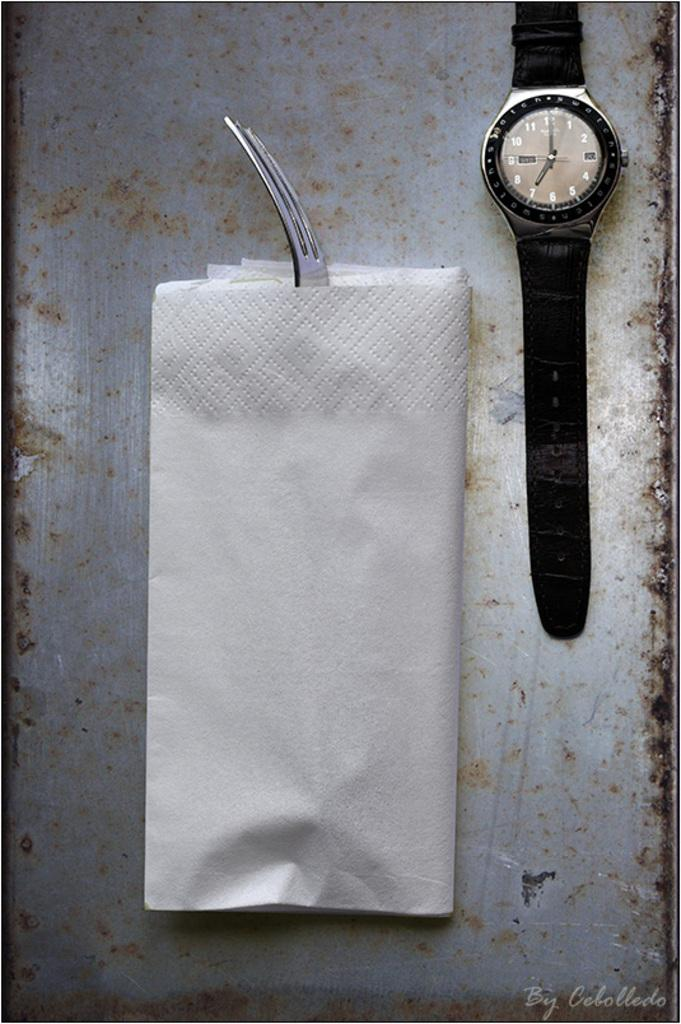<image>
Present a compact description of the photo's key features. A wrist watch showing the time of 7:00 sits next to a napkin and fork. 